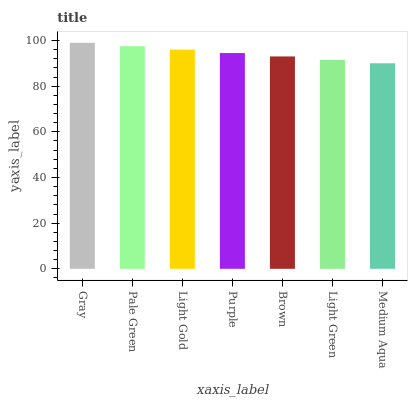Is Medium Aqua the minimum?
Answer yes or no. Yes. Is Gray the maximum?
Answer yes or no. Yes. Is Pale Green the minimum?
Answer yes or no. No. Is Pale Green the maximum?
Answer yes or no. No. Is Gray greater than Pale Green?
Answer yes or no. Yes. Is Pale Green less than Gray?
Answer yes or no. Yes. Is Pale Green greater than Gray?
Answer yes or no. No. Is Gray less than Pale Green?
Answer yes or no. No. Is Purple the high median?
Answer yes or no. Yes. Is Purple the low median?
Answer yes or no. Yes. Is Medium Aqua the high median?
Answer yes or no. No. Is Pale Green the low median?
Answer yes or no. No. 